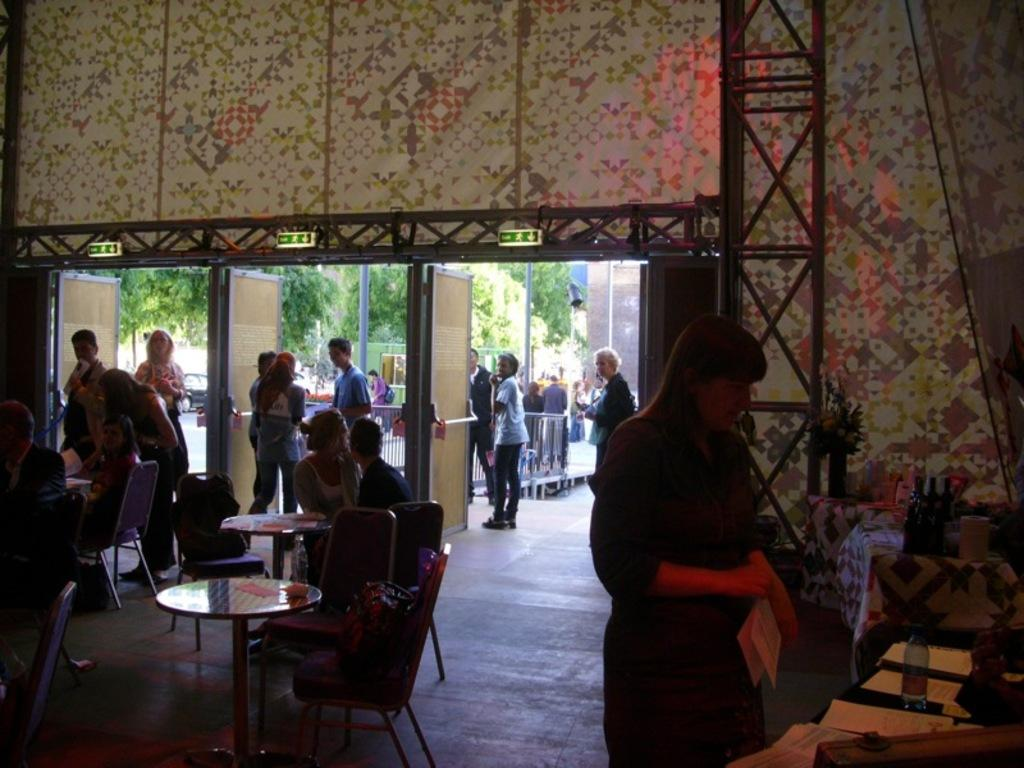Who is present in the image? There are people in the image. What are the people doing at the location? The people are entering or exiting at a gate. Where is the gate located? The gate is located at a restaurant. How many cars can be seen parked near the gate at the restaurant? There is no mention of cars in the image, so it is not possible to determine how many cars might be parked nearby. 